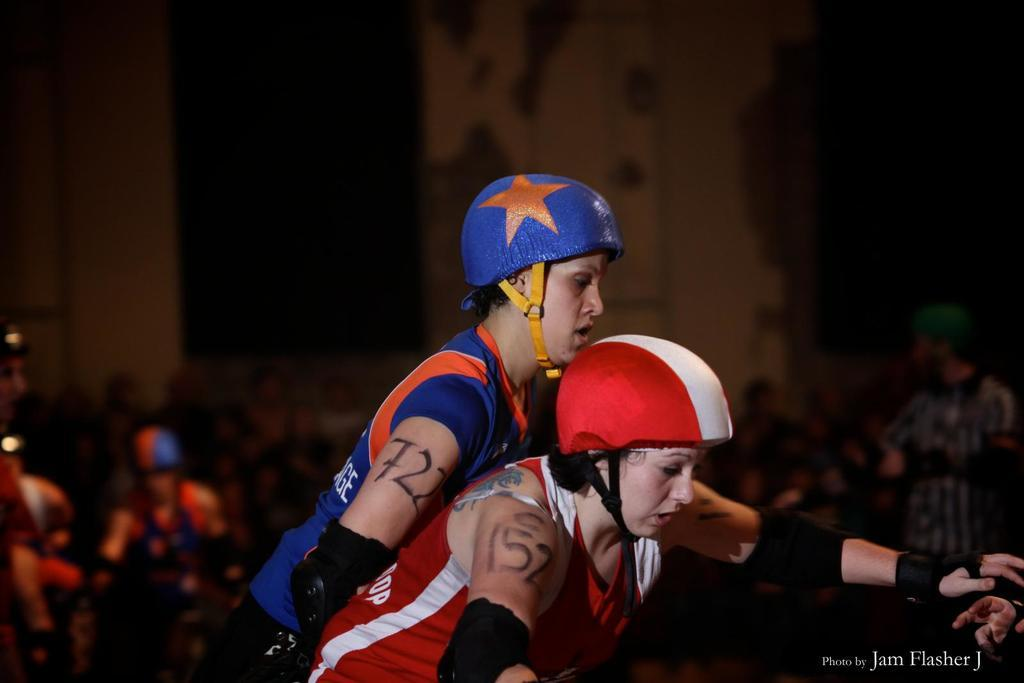Who is present in the image? There are women and a man in the image. What are the women wearing? The women are wearing helmets. What can be seen in the background of the image? There is a building in the image. What are some people doing in the image? Some people are seated in the image. Can you tell me the position of the tent in the image? There is no tent present in the image. What type of lake can be seen in the image? There is no lake present in the image. 